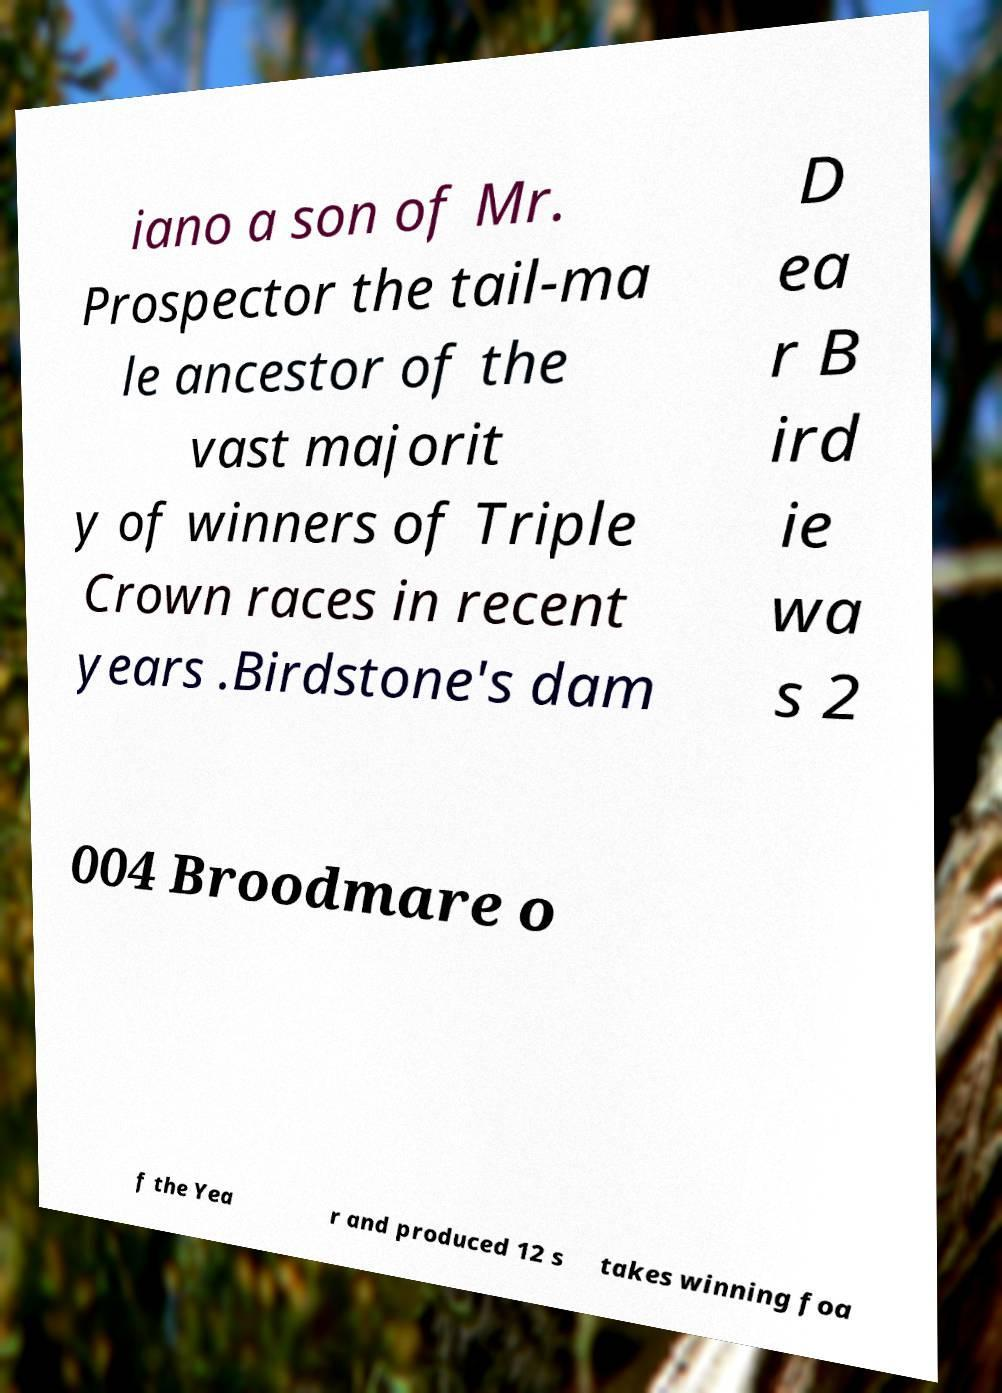For documentation purposes, I need the text within this image transcribed. Could you provide that? iano a son of Mr. Prospector the tail-ma le ancestor of the vast majorit y of winners of Triple Crown races in recent years .Birdstone's dam D ea r B ird ie wa s 2 004 Broodmare o f the Yea r and produced 12 s takes winning foa 